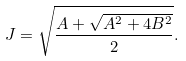Convert formula to latex. <formula><loc_0><loc_0><loc_500><loc_500>J = \sqrt { \frac { A + \sqrt { A ^ { 2 } + 4 B ^ { 2 } } } { 2 } } .</formula> 